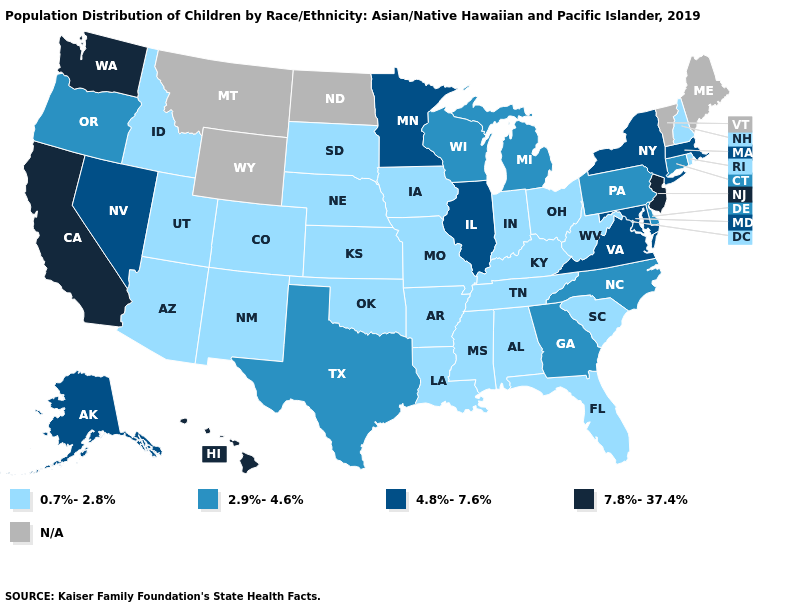What is the value of Nevada?
Keep it brief. 4.8%-7.6%. Which states have the highest value in the USA?
Answer briefly. California, Hawaii, New Jersey, Washington. What is the value of Louisiana?
Give a very brief answer. 0.7%-2.8%. What is the value of Indiana?
Keep it brief. 0.7%-2.8%. What is the value of Kansas?
Answer briefly. 0.7%-2.8%. What is the value of Massachusetts?
Be succinct. 4.8%-7.6%. What is the value of Mississippi?
Write a very short answer. 0.7%-2.8%. What is the lowest value in the Northeast?
Concise answer only. 0.7%-2.8%. Name the states that have a value in the range 2.9%-4.6%?
Write a very short answer. Connecticut, Delaware, Georgia, Michigan, North Carolina, Oregon, Pennsylvania, Texas, Wisconsin. Name the states that have a value in the range 2.9%-4.6%?
Be succinct. Connecticut, Delaware, Georgia, Michigan, North Carolina, Oregon, Pennsylvania, Texas, Wisconsin. What is the value of Hawaii?
Give a very brief answer. 7.8%-37.4%. Does Pennsylvania have the lowest value in the USA?
Quick response, please. No. What is the value of Minnesota?
Be succinct. 4.8%-7.6%. 